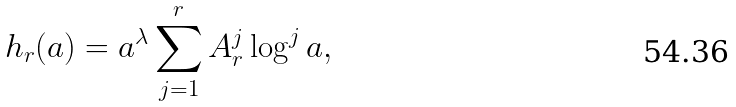<formula> <loc_0><loc_0><loc_500><loc_500>h _ { r } ( a ) = a ^ { \lambda } \sum _ { j = 1 } ^ { r } A _ { r } ^ { j } \log ^ { j } a ,</formula> 